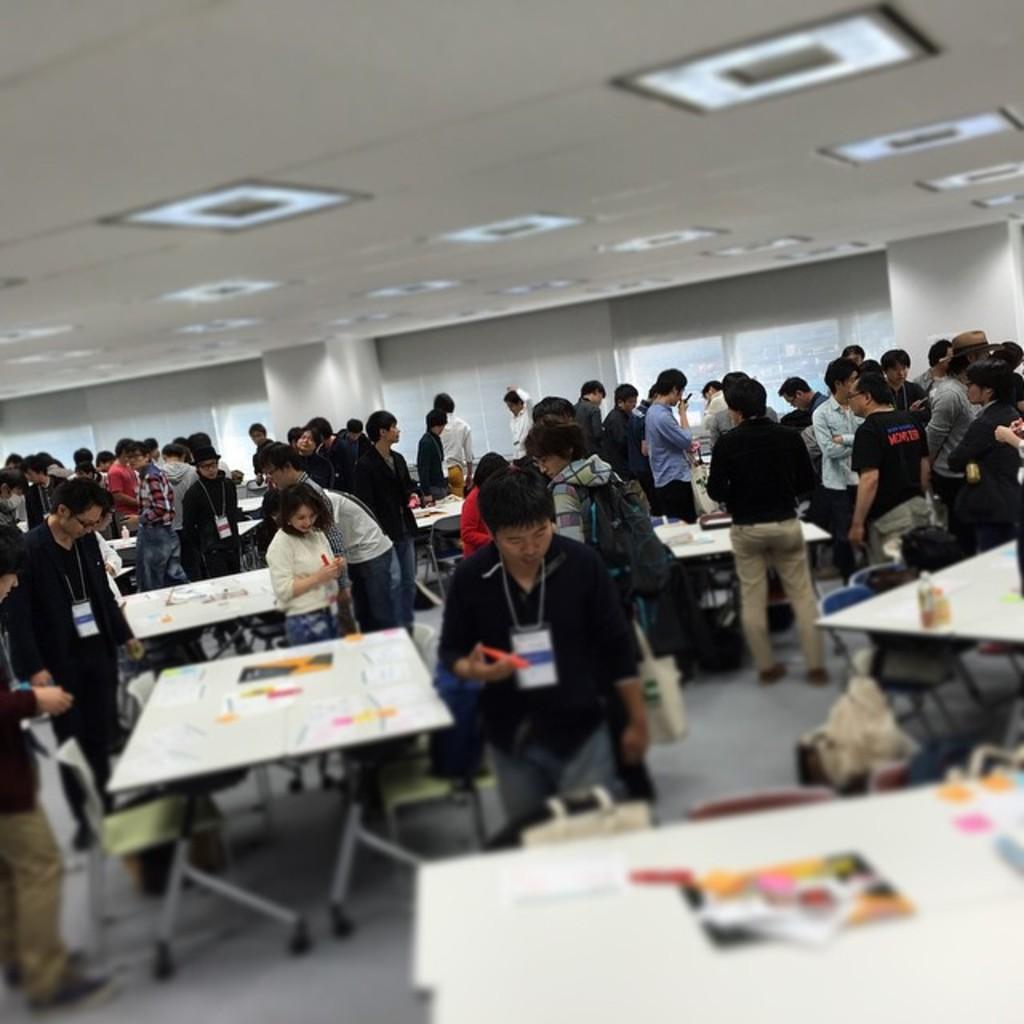Can you describe this image briefly? There is a big hall which has ceiling and a lights at the top at the bottom their is a table which has papers on it and the people are busy in their work and the people are wearing an id card and there are people who are holding bags. And there are chairs at the right corner and their is a man who is standing and looking at others. 